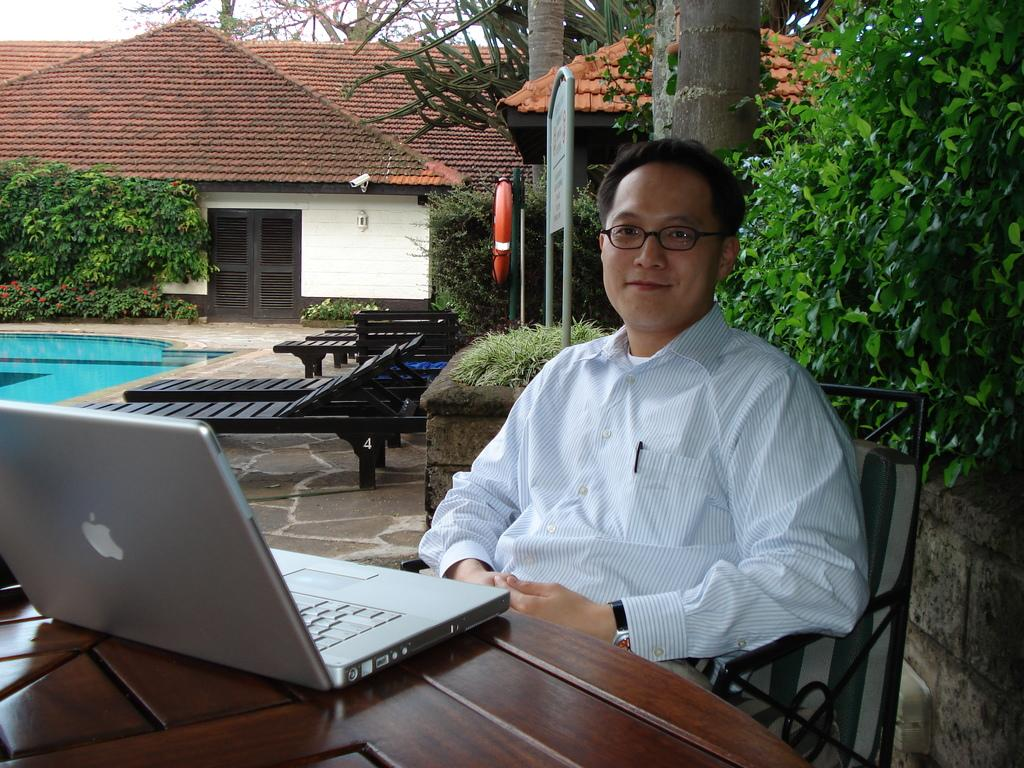What is the man in the image doing? The man is sitting on a chair in the image. What object is on the table in the image? There is a laptop on a table in the image. What type of seating is visible in the image? There is a bench in the image. What body of water is present in the image? There is a swimming pool in the image. What type of vegetation is in the image? There are plants in the image. What type of building is in the image? There is a house in the image. What is the rubber tube used for in the image? There is a rubber tube in the image, but its purpose is not clear from the facts provided. What type of question is being asked in the image? There is no indication of a question being asked in the image. What type of cart is visible in the image? There is no cart present in the image. 